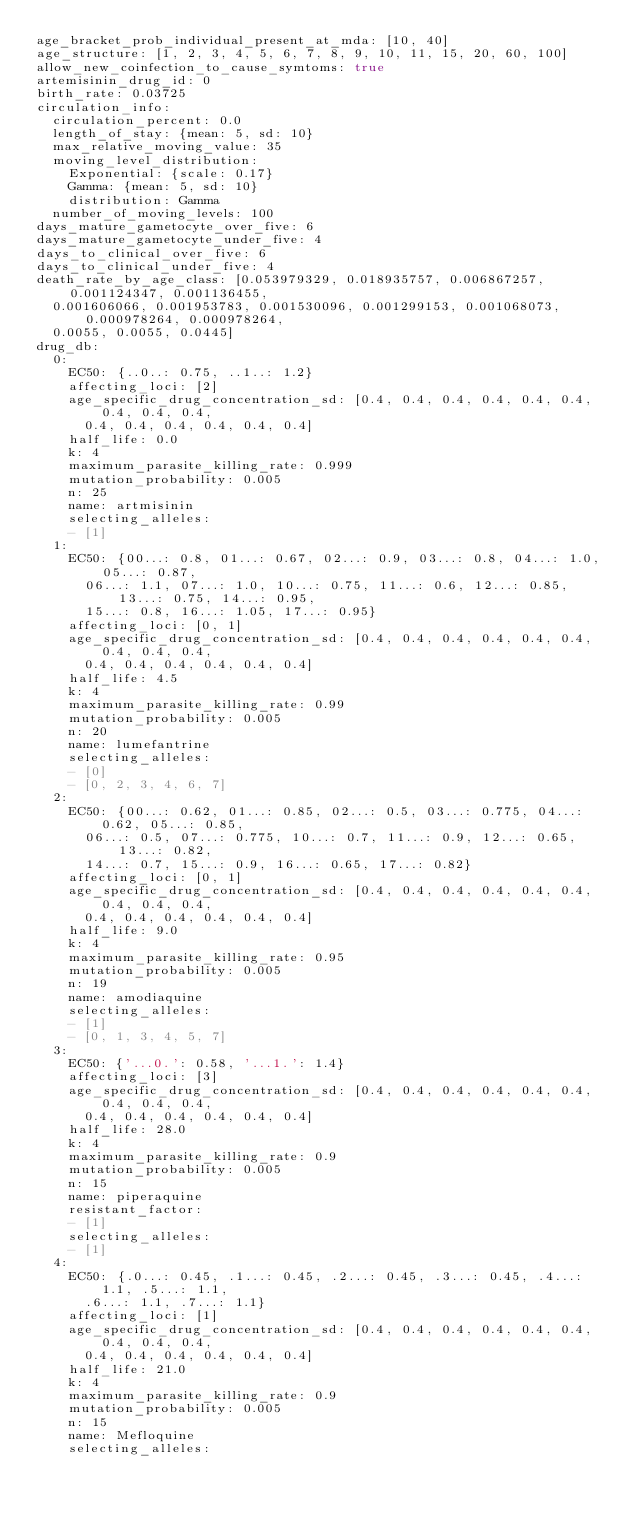Convert code to text. <code><loc_0><loc_0><loc_500><loc_500><_YAML_>age_bracket_prob_individual_present_at_mda: [10, 40]
age_structure: [1, 2, 3, 4, 5, 6, 7, 8, 9, 10, 11, 15, 20, 60, 100]
allow_new_coinfection_to_cause_symtoms: true
artemisinin_drug_id: 0
birth_rate: 0.03725
circulation_info:
  circulation_percent: 0.0
  length_of_stay: {mean: 5, sd: 10}
  max_relative_moving_value: 35
  moving_level_distribution:
    Exponential: {scale: 0.17}
    Gamma: {mean: 5, sd: 10}
    distribution: Gamma
  number_of_moving_levels: 100
days_mature_gametocyte_over_five: 6
days_mature_gametocyte_under_five: 4
days_to_clinical_over_five: 6
days_to_clinical_under_five: 4
death_rate_by_age_class: [0.053979329, 0.018935757, 0.006867257, 0.001124347, 0.001136455,
  0.001606066, 0.001953783, 0.001530096, 0.001299153, 0.001068073, 0.000978264, 0.000978264,
  0.0055, 0.0055, 0.0445]
drug_db:
  0:
    EC50: {..0..: 0.75, ..1..: 1.2}
    affecting_loci: [2]
    age_specific_drug_concentration_sd: [0.4, 0.4, 0.4, 0.4, 0.4, 0.4, 0.4, 0.4, 0.4,
      0.4, 0.4, 0.4, 0.4, 0.4, 0.4]
    half_life: 0.0
    k: 4
    maximum_parasite_killing_rate: 0.999
    mutation_probability: 0.005
    n: 25
    name: artmisinin
    selecting_alleles:
    - [1]
  1:
    EC50: {00...: 0.8, 01...: 0.67, 02...: 0.9, 03...: 0.8, 04...: 1.0, 05...: 0.87,
      06...: 1.1, 07...: 1.0, 10...: 0.75, 11...: 0.6, 12...: 0.85, 13...: 0.75, 14...: 0.95,
      15...: 0.8, 16...: 1.05, 17...: 0.95}
    affecting_loci: [0, 1]
    age_specific_drug_concentration_sd: [0.4, 0.4, 0.4, 0.4, 0.4, 0.4, 0.4, 0.4, 0.4,
      0.4, 0.4, 0.4, 0.4, 0.4, 0.4]
    half_life: 4.5
    k: 4
    maximum_parasite_killing_rate: 0.99
    mutation_probability: 0.005
    n: 20
    name: lumefantrine
    selecting_alleles:
    - [0]
    - [0, 2, 3, 4, 6, 7]
  2:
    EC50: {00...: 0.62, 01...: 0.85, 02...: 0.5, 03...: 0.775, 04...: 0.62, 05...: 0.85,
      06...: 0.5, 07...: 0.775, 10...: 0.7, 11...: 0.9, 12...: 0.65, 13...: 0.82,
      14...: 0.7, 15...: 0.9, 16...: 0.65, 17...: 0.82}
    affecting_loci: [0, 1]
    age_specific_drug_concentration_sd: [0.4, 0.4, 0.4, 0.4, 0.4, 0.4, 0.4, 0.4, 0.4,
      0.4, 0.4, 0.4, 0.4, 0.4, 0.4]
    half_life: 9.0
    k: 4
    maximum_parasite_killing_rate: 0.95
    mutation_probability: 0.005
    n: 19
    name: amodiaquine
    selecting_alleles:
    - [1]
    - [0, 1, 3, 4, 5, 7]
  3:
    EC50: {'...0.': 0.58, '...1.': 1.4}
    affecting_loci: [3]
    age_specific_drug_concentration_sd: [0.4, 0.4, 0.4, 0.4, 0.4, 0.4, 0.4, 0.4, 0.4,
      0.4, 0.4, 0.4, 0.4, 0.4, 0.4]
    half_life: 28.0
    k: 4
    maximum_parasite_killing_rate: 0.9
    mutation_probability: 0.005
    n: 15
    name: piperaquine
    resistant_factor:
    - [1]
    selecting_alleles:
    - [1]
  4:
    EC50: {.0...: 0.45, .1...: 0.45, .2...: 0.45, .3...: 0.45, .4...: 1.1, .5...: 1.1,
      .6...: 1.1, .7...: 1.1}
    affecting_loci: [1]
    age_specific_drug_concentration_sd: [0.4, 0.4, 0.4, 0.4, 0.4, 0.4, 0.4, 0.4, 0.4,
      0.4, 0.4, 0.4, 0.4, 0.4, 0.4]
    half_life: 21.0
    k: 4
    maximum_parasite_killing_rate: 0.9
    mutation_probability: 0.005
    n: 15
    name: Mefloquine
    selecting_alleles:</code> 